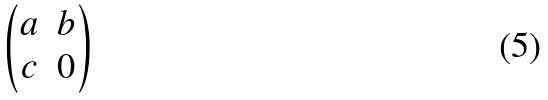Convert formula to latex. <formula><loc_0><loc_0><loc_500><loc_500>\begin{pmatrix} a & b \\ c & 0 \end{pmatrix}</formula> 